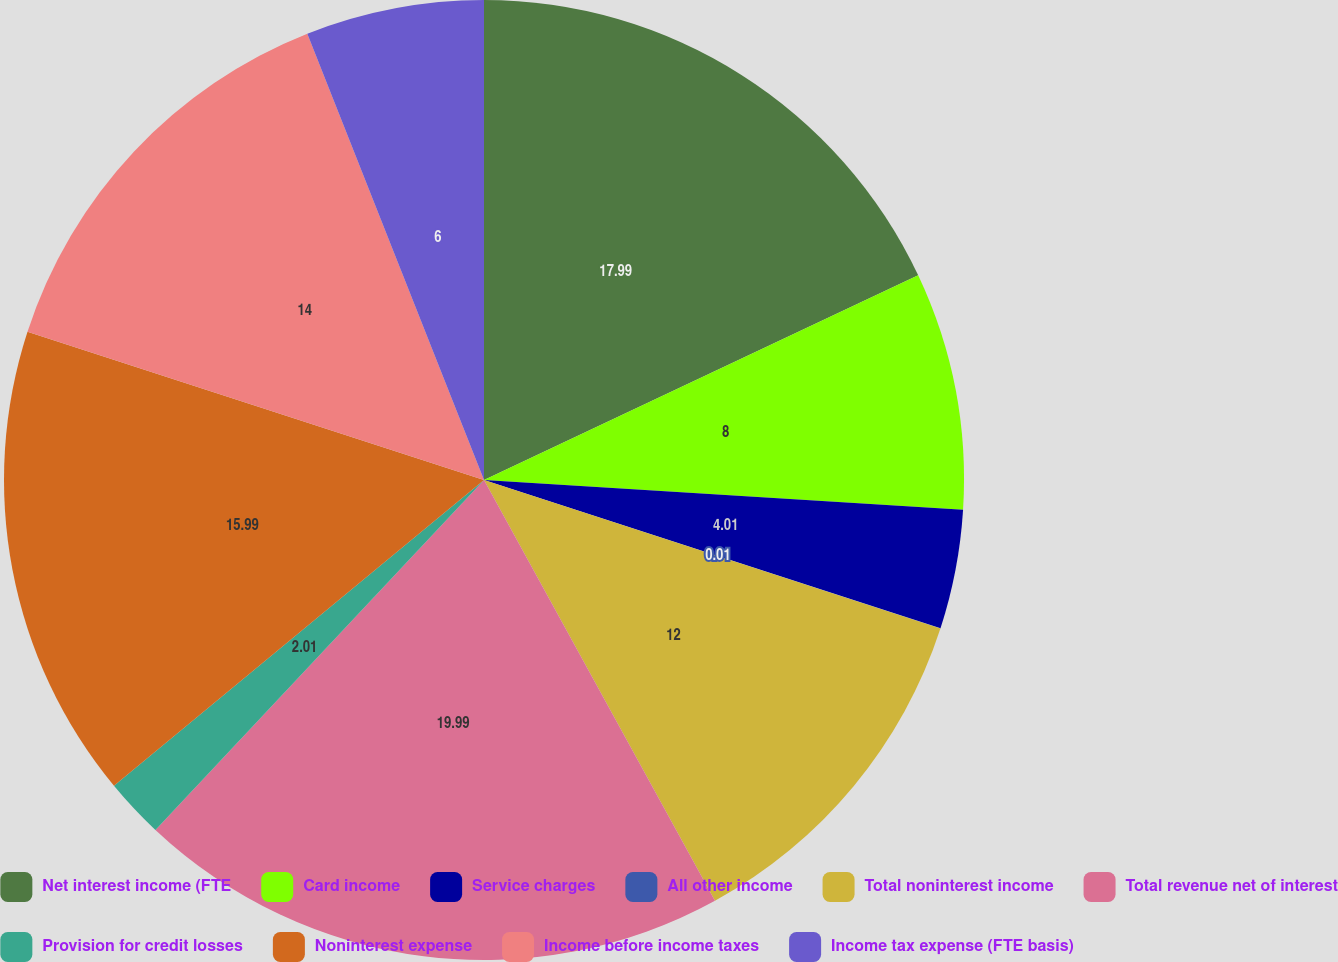<chart> <loc_0><loc_0><loc_500><loc_500><pie_chart><fcel>Net interest income (FTE<fcel>Card income<fcel>Service charges<fcel>All other income<fcel>Total noninterest income<fcel>Total revenue net of interest<fcel>Provision for credit losses<fcel>Noninterest expense<fcel>Income before income taxes<fcel>Income tax expense (FTE basis)<nl><fcel>17.99%<fcel>8.0%<fcel>4.01%<fcel>0.01%<fcel>12.0%<fcel>19.99%<fcel>2.01%<fcel>15.99%<fcel>14.0%<fcel>6.0%<nl></chart> 